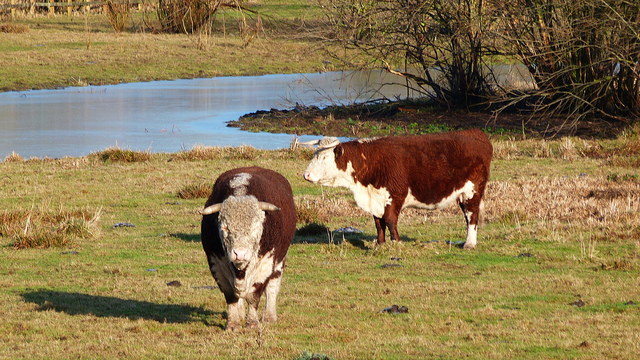How many cows can be seen? 2 